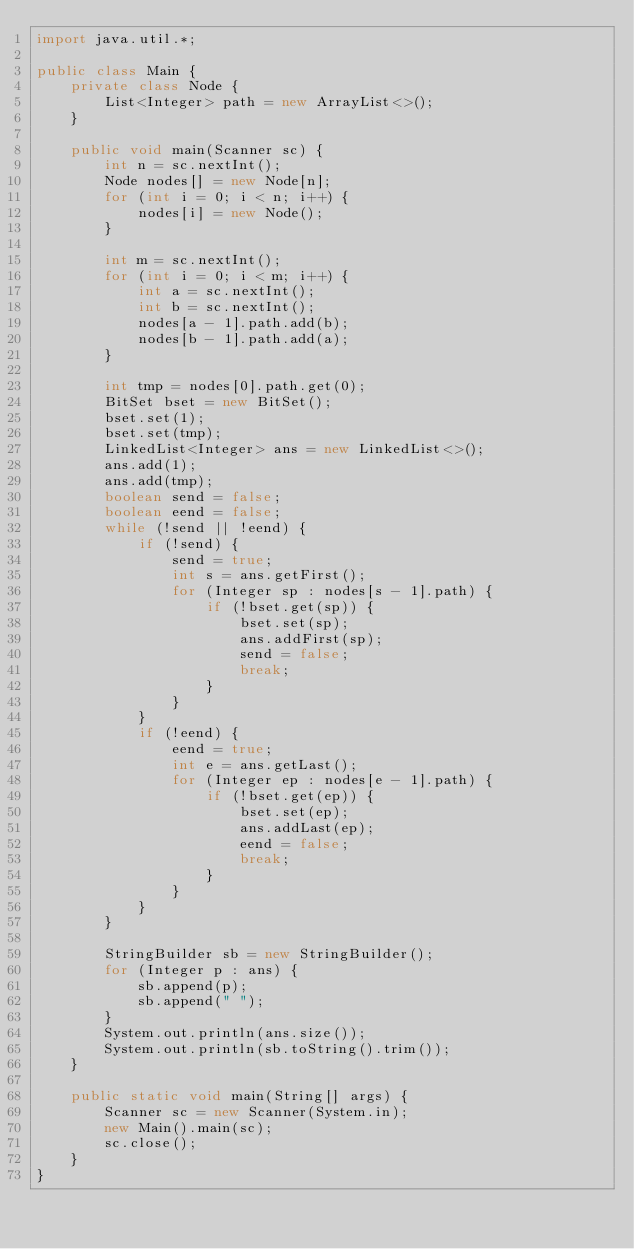<code> <loc_0><loc_0><loc_500><loc_500><_Java_>import java.util.*;

public class Main {
    private class Node {
        List<Integer> path = new ArrayList<>();
    }

    public void main(Scanner sc) {
        int n = sc.nextInt();
        Node nodes[] = new Node[n];
        for (int i = 0; i < n; i++) {
            nodes[i] = new Node();
        }

        int m = sc.nextInt();
        for (int i = 0; i < m; i++) {
            int a = sc.nextInt();
            int b = sc.nextInt();
            nodes[a - 1].path.add(b);
            nodes[b - 1].path.add(a);
        }

        int tmp = nodes[0].path.get(0);
        BitSet bset = new BitSet();
        bset.set(1);
        bset.set(tmp);
        LinkedList<Integer> ans = new LinkedList<>();
        ans.add(1);
        ans.add(tmp);
        boolean send = false;
        boolean eend = false;
        while (!send || !eend) {
            if (!send) {
                send = true;
                int s = ans.getFirst();
                for (Integer sp : nodes[s - 1].path) {
                    if (!bset.get(sp)) {
                        bset.set(sp);
                        ans.addFirst(sp);
                        send = false;
                        break;
                    }
                }
            }
            if (!eend) {
                eend = true;
                int e = ans.getLast();
                for (Integer ep : nodes[e - 1].path) {
                    if (!bset.get(ep)) {
                        bset.set(ep);
                        ans.addLast(ep);
                        eend = false;
                        break;
                    }
                }
            }
        }

        StringBuilder sb = new StringBuilder();
        for (Integer p : ans) {
            sb.append(p);
            sb.append(" ");
        }
        System.out.println(ans.size());
        System.out.println(sb.toString().trim());
    }

    public static void main(String[] args) {
        Scanner sc = new Scanner(System.in);
        new Main().main(sc);
        sc.close();
    }
}
</code> 